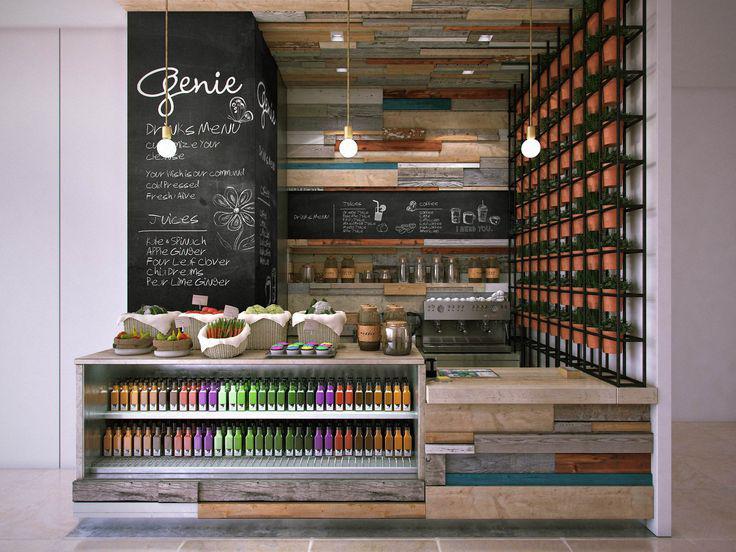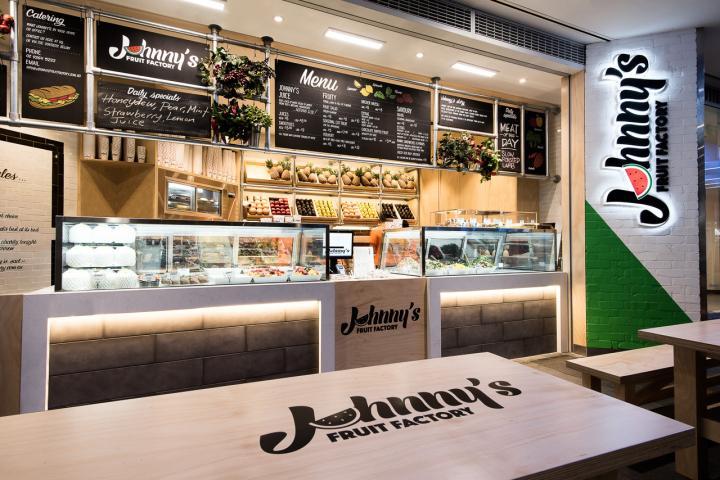The first image is the image on the left, the second image is the image on the right. Evaluate the accuracy of this statement regarding the images: "An image shows the front of an eatery inside a bigger building, with signage that includes bright green color and a red fruit.". Is it true? Answer yes or no. Yes. 